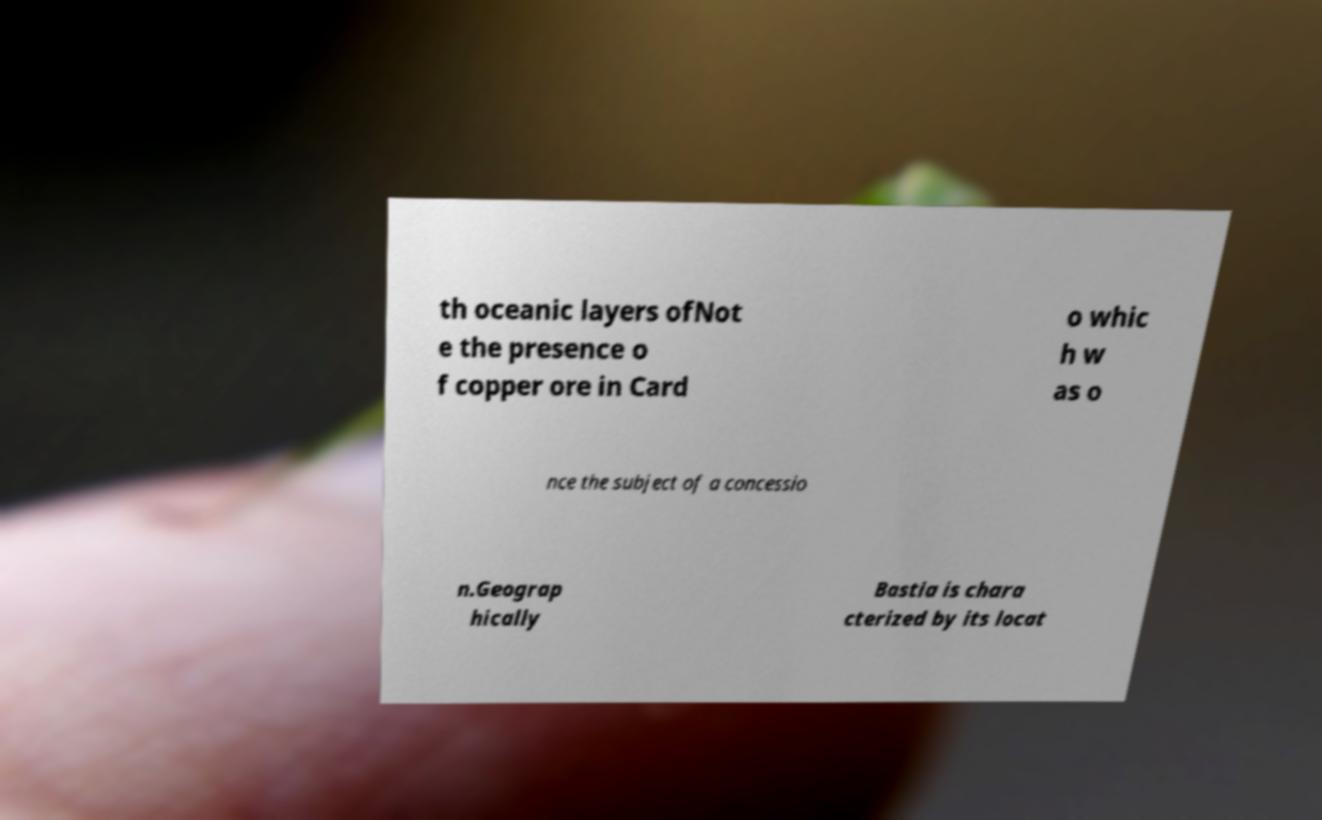Please read and relay the text visible in this image. What does it say? th oceanic layers ofNot e the presence o f copper ore in Card o whic h w as o nce the subject of a concessio n.Geograp hically Bastia is chara cterized by its locat 